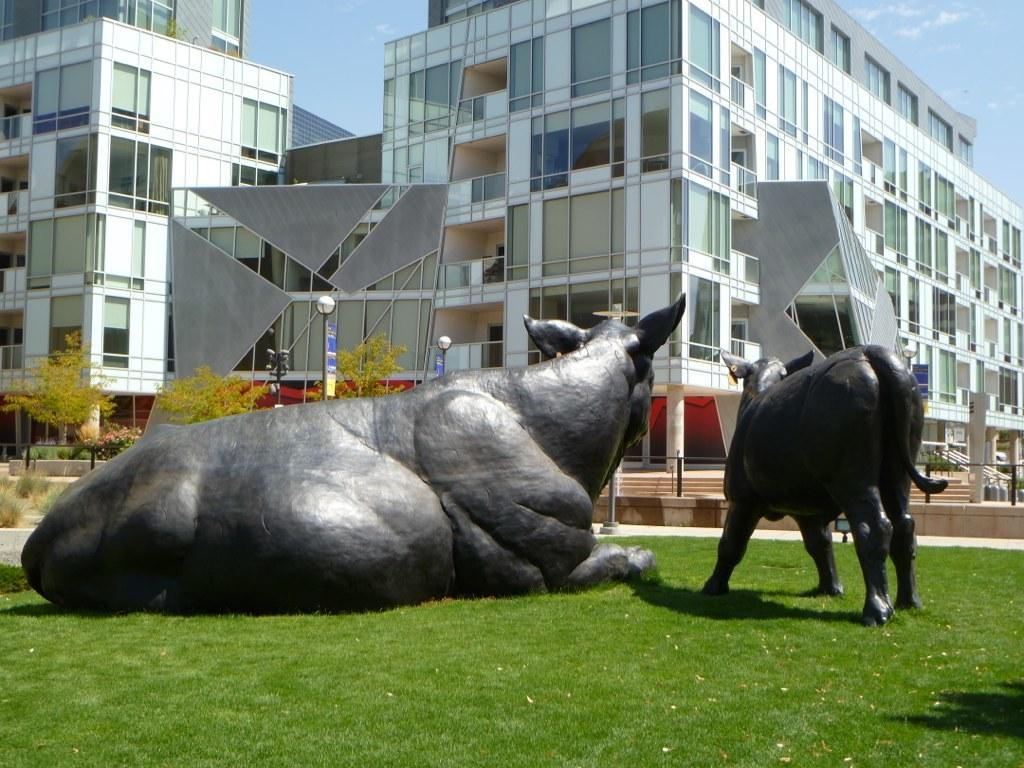What type of structures can be seen in the image? There are buildings in the image. What other living beings are present in the image besides humans? There are animals in the image. What type of vegetation is visible in the image? There are trees in the image. What type of lace can be seen on the buildings in the image? There is no lace present on the buildings in the image. What is the current state of peace in the image? The image does not depict a specific state of peace or conflict; it simply shows buildings, animals, and trees. 